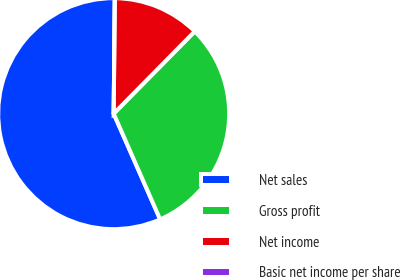Convert chart to OTSL. <chart><loc_0><loc_0><loc_500><loc_500><pie_chart><fcel>Net sales<fcel>Gross profit<fcel>Net income<fcel>Basic net income per share<nl><fcel>56.75%<fcel>31.03%<fcel>12.23%<fcel>0.0%<nl></chart> 